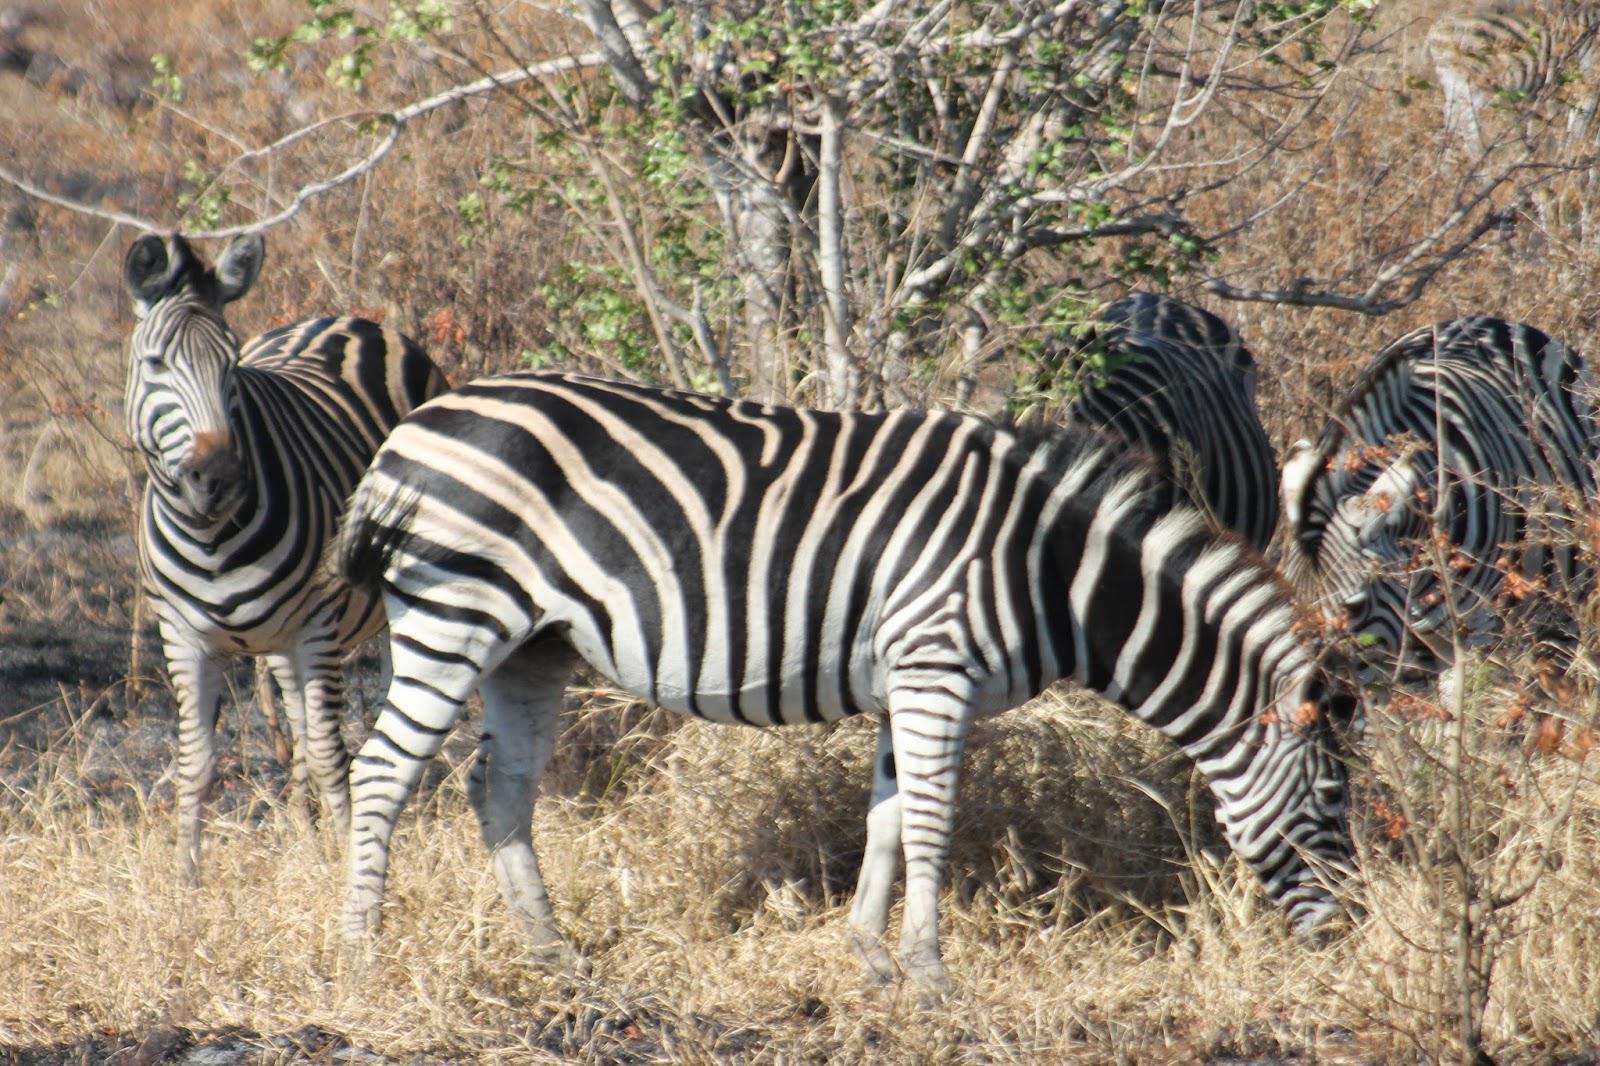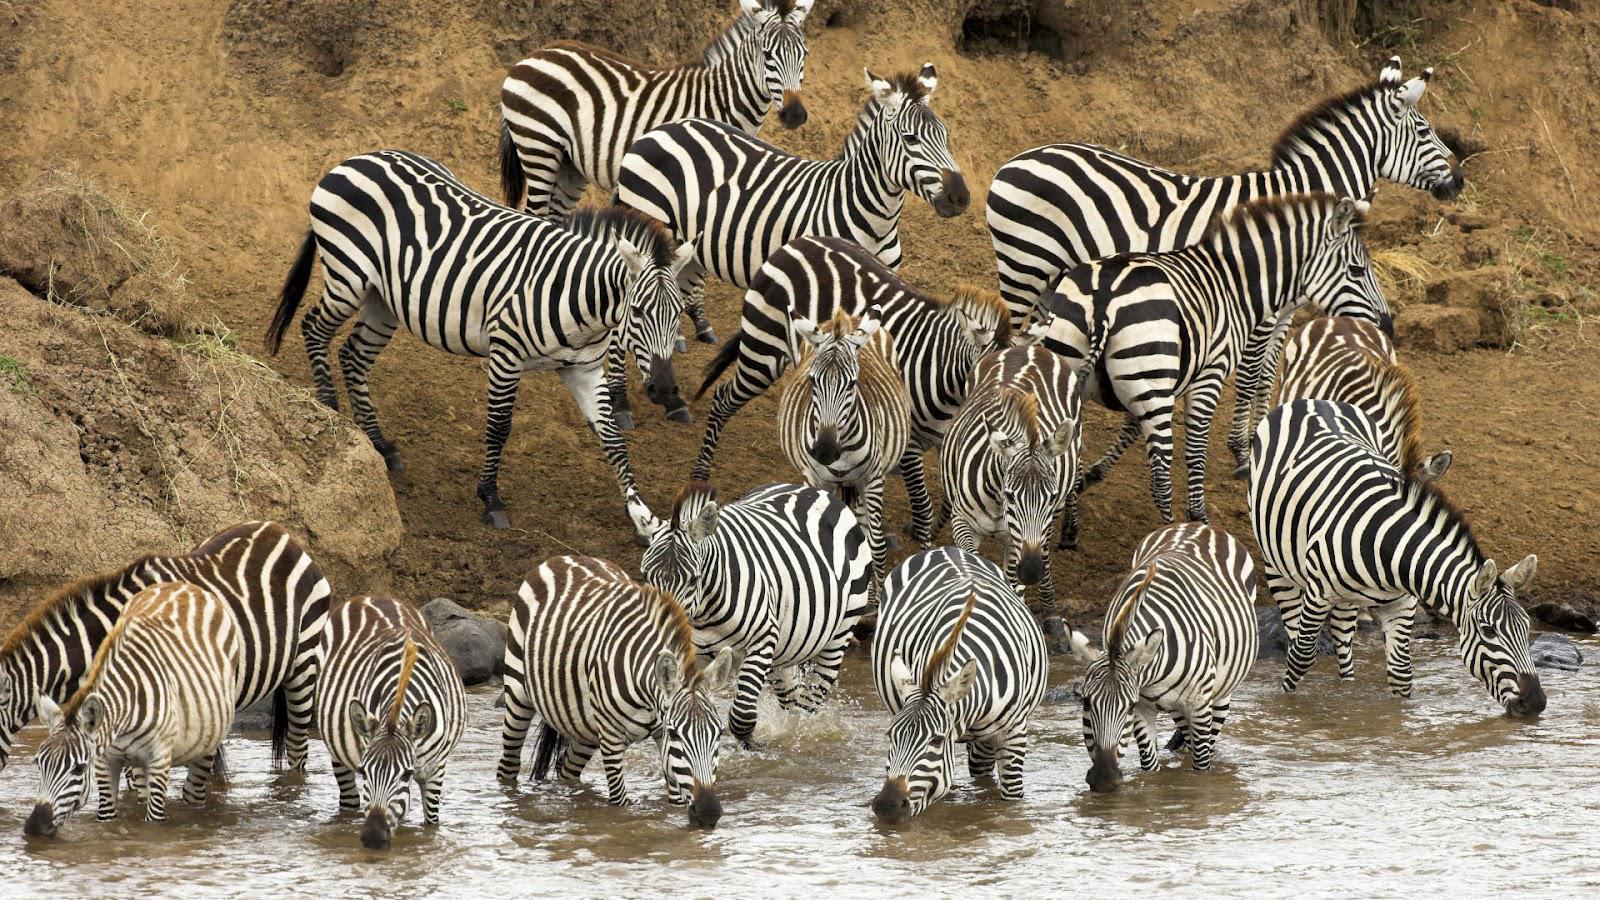The first image is the image on the left, the second image is the image on the right. Assess this claim about the two images: "One image shows multiple zebras standing in water up to their knees, and the other image shows multiple zebras standing on dry ground.". Correct or not? Answer yes or no. Yes. The first image is the image on the left, the second image is the image on the right. For the images shown, is this caption "One image shows zebras in water and the other image shows zebras on grassland." true? Answer yes or no. Yes. 